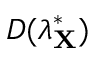<formula> <loc_0><loc_0><loc_500><loc_500>D ( \lambda _ { X } ^ { * } )</formula> 